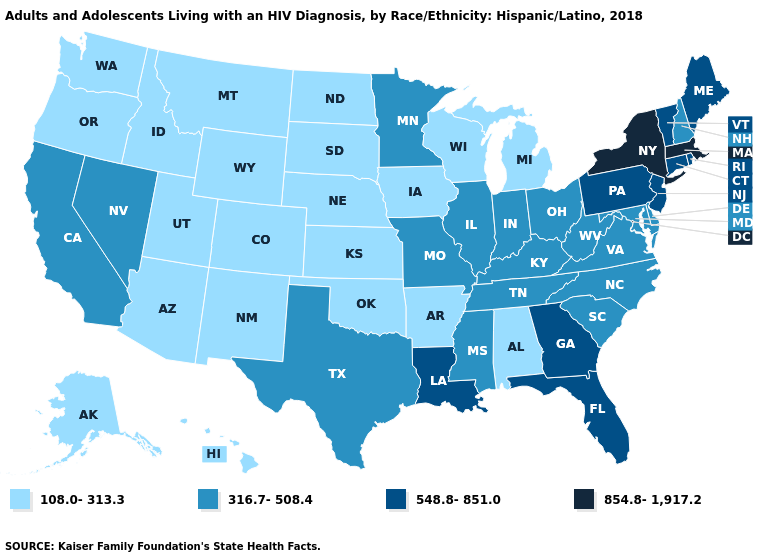What is the lowest value in the USA?
Quick response, please. 108.0-313.3. Does Alabama have the lowest value in the South?
Give a very brief answer. Yes. Does Nebraska have a lower value than Pennsylvania?
Answer briefly. Yes. What is the value of Nebraska?
Be succinct. 108.0-313.3. Does the first symbol in the legend represent the smallest category?
Keep it brief. Yes. Is the legend a continuous bar?
Write a very short answer. No. What is the value of Florida?
Write a very short answer. 548.8-851.0. What is the value of Missouri?
Answer briefly. 316.7-508.4. Does New Jersey have the lowest value in the USA?
Answer briefly. No. What is the value of Washington?
Concise answer only. 108.0-313.3. Does New Hampshire have the lowest value in the USA?
Short answer required. No. Does Utah have the highest value in the West?
Be succinct. No. Name the states that have a value in the range 854.8-1,917.2?
Keep it brief. Massachusetts, New York. What is the value of Georgia?
Quick response, please. 548.8-851.0. What is the value of Kansas?
Short answer required. 108.0-313.3. 